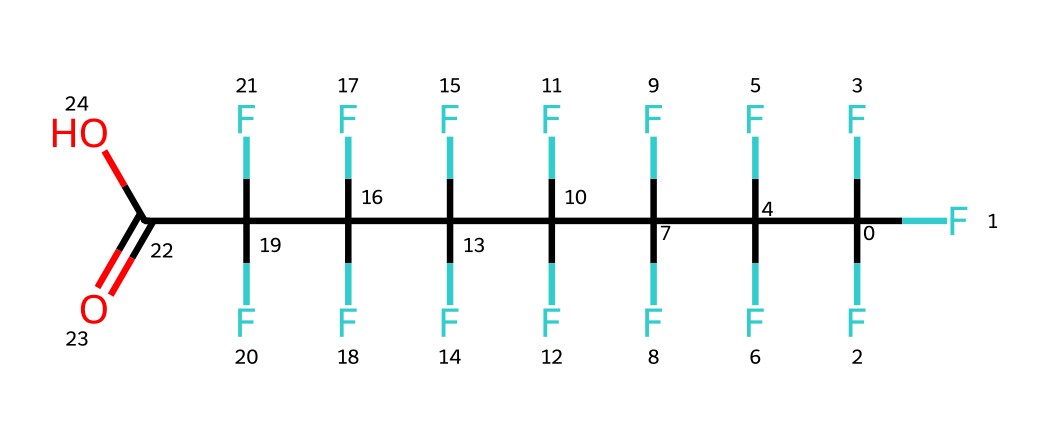How many carbon atoms are in perfluorooctanoic acid? The chemical structure contains a chain of eight carbon atoms connected linearly, identifiable by the "C" atoms in the SMILES notation. Each carbon atom is central to each segment of the molecule.
Answer: eight What is the functional group present in this molecule? The ending part of the SMILES notation "C(=O)O" indicates the presence of a carboxylic acid functional group, which is characterized by a carbon atom double bonded to an oxygen atom and single bonded to a hydroxyl group.
Answer: carboxylic acid How many fluorine atoms are in perfluorooctanoic acid? Counting the "F" atoms in the SMILES string, there are a total of 16 fluorine atoms attached to the carbon backbone of the molecule, which corresponds to the repeating pattern before reaching the carboxylic acid.
Answer: sixteen What is the primary use of perfluorooctanoic acid? PFOA is primarily used in the manufacturing of non-stick coatings, such as those found on cookware, which utilize its properties to repel water and grease, making the surface easy to clean.
Answer: non-stick coatings What type of environmental concern is associated with perfluorooctanoic acid? PFOA is known to be persistent in the environment and has been associated with numerous health risks; this is due to its resistance to degradation and accumulation in living organisms, leading to pollution and toxicity over time.
Answer: persistent environmental pollutant Why is perfluorooctanoic acid considered a toxic chemical? PFOA has been linked to various adverse health effects, including cancer and immune system effects, making it classified as a toxic chemical. Its structure, with multiple fluorinated carbons, contributes to its chemical stability and toxicity.
Answer: toxic 